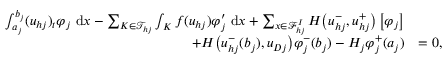Convert formula to latex. <formula><loc_0><loc_0><loc_500><loc_500>\begin{array} { r l } { \int _ { a _ { j } } ^ { b _ { j } } ( { u } _ { h j } ) _ { t } \varphi _ { j } \ d x - \sum _ { K \in \mathcal { T } _ { h j } } \int _ { K } { f } ( { u } _ { h j } ) \varphi _ { j } ^ { \prime } \ d x + \sum _ { x \in \mathcal { F } _ { h j } ^ { I } } H \left ( { u } _ { h j } ^ { - } , { u } _ { h j } ^ { + } \right ) \left [ \varphi _ { j } \right ] } \\ { \quad + H \left ( { u } _ { h j } ^ { - } ( b _ { j } ) , { u } _ { D j } \right ) \varphi _ { j } ^ { - } ( b _ { j } ) - H _ { j } \varphi _ { j } ^ { + } ( a _ { j } ) } & { = 0 , } \end{array}</formula> 